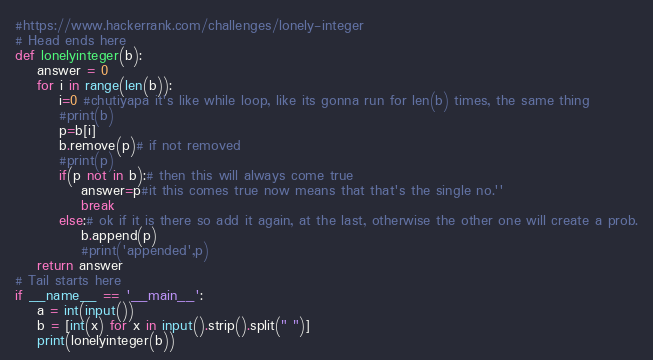<code> <loc_0><loc_0><loc_500><loc_500><_Python_>#https://www.hackerrank.com/challenges/lonely-integer
# Head ends here
def lonelyinteger(b):
	answer = 0
	for i in range(len(b)):
		i=0 #chutiyapa it's like while loop, like its gonna run for len(b) times, the same thing
		#print(b)
		p=b[i]
		b.remove(p)# if not removed
		#print(p)
		if(p not in b):# then this will always come true
			answer=p#it this comes true now means that that's the single no.''
			break
		else:# ok if it is there so add it again, at the last, otherwise the other one will create a prob.
			b.append(p)
			#print('appended',p)
	return answer
# Tail starts here
if __name__ == '__main__':
	a = int(input())
	b = [int(x) for x in input().strip().split(" ")]
	print(lonelyinteger(b))
</code> 